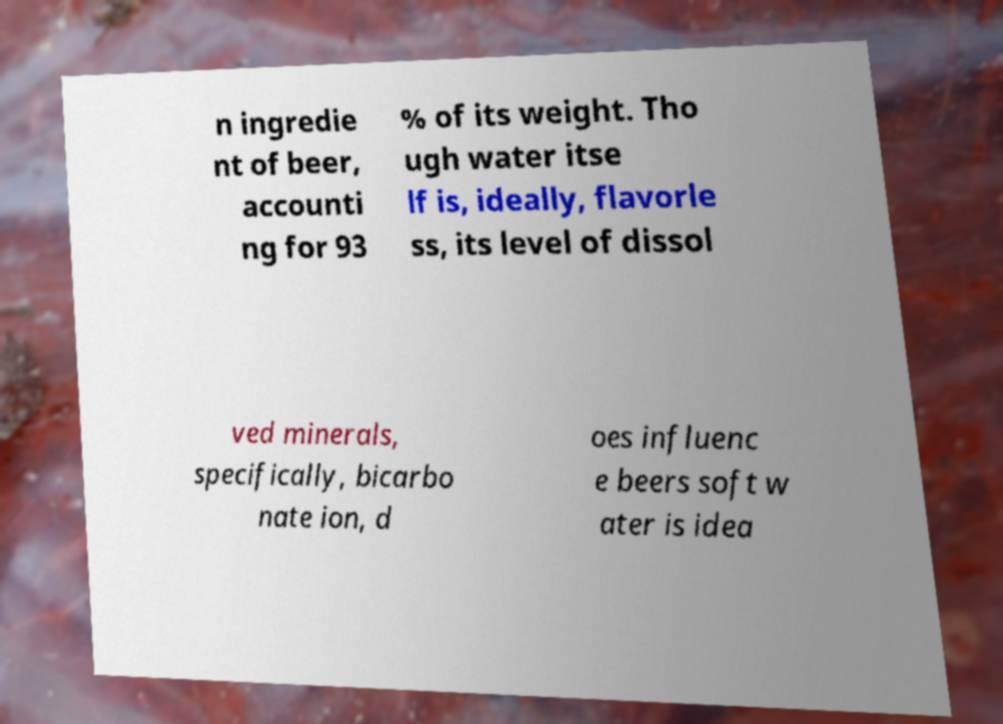I need the written content from this picture converted into text. Can you do that? n ingredie nt of beer, accounti ng for 93 % of its weight. Tho ugh water itse lf is, ideally, flavorle ss, its level of dissol ved minerals, specifically, bicarbo nate ion, d oes influenc e beers soft w ater is idea 